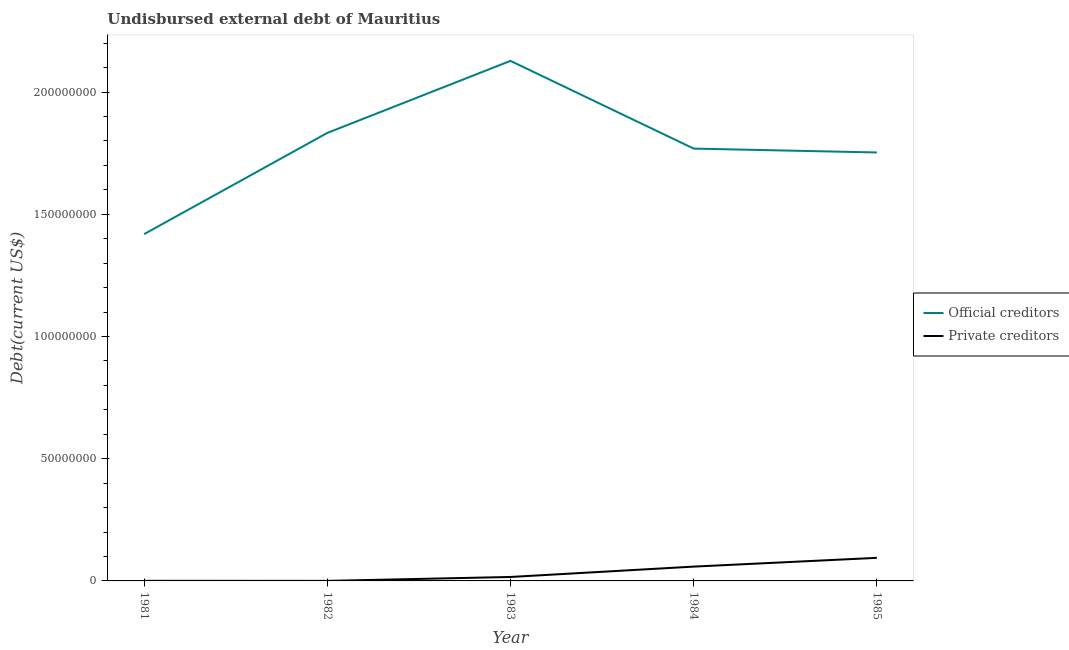How many different coloured lines are there?
Your answer should be very brief. 2. Is the number of lines equal to the number of legend labels?
Your response must be concise. Yes. What is the undisbursed external debt of private creditors in 1985?
Offer a terse response. 9.44e+06. Across all years, what is the maximum undisbursed external debt of official creditors?
Give a very brief answer. 2.13e+08. Across all years, what is the minimum undisbursed external debt of private creditors?
Give a very brief answer. 1.90e+04. In which year was the undisbursed external debt of official creditors maximum?
Your answer should be very brief. 1983. What is the total undisbursed external debt of private creditors in the graph?
Ensure brevity in your answer.  1.70e+07. What is the difference between the undisbursed external debt of private creditors in 1982 and that in 1984?
Ensure brevity in your answer.  -5.84e+06. What is the difference between the undisbursed external debt of private creditors in 1983 and the undisbursed external debt of official creditors in 1985?
Your response must be concise. -1.74e+08. What is the average undisbursed external debt of private creditors per year?
Your answer should be compact. 3.40e+06. In the year 1983, what is the difference between the undisbursed external debt of private creditors and undisbursed external debt of official creditors?
Offer a very short reply. -2.11e+08. In how many years, is the undisbursed external debt of official creditors greater than 210000000 US$?
Your response must be concise. 1. What is the ratio of the undisbursed external debt of private creditors in 1981 to that in 1984?
Your answer should be very brief. 0.01. Is the undisbursed external debt of private creditors in 1982 less than that in 1985?
Provide a succinct answer. Yes. Is the difference between the undisbursed external debt of official creditors in 1983 and 1984 greater than the difference between the undisbursed external debt of private creditors in 1983 and 1984?
Give a very brief answer. Yes. What is the difference between the highest and the second highest undisbursed external debt of private creditors?
Make the answer very short. 3.58e+06. What is the difference between the highest and the lowest undisbursed external debt of private creditors?
Offer a terse response. 9.42e+06. Is the sum of the undisbursed external debt of official creditors in 1981 and 1984 greater than the maximum undisbursed external debt of private creditors across all years?
Provide a short and direct response. Yes. Is the undisbursed external debt of private creditors strictly greater than the undisbursed external debt of official creditors over the years?
Offer a very short reply. No. How many years are there in the graph?
Give a very brief answer. 5. What is the difference between two consecutive major ticks on the Y-axis?
Your response must be concise. 5.00e+07. How many legend labels are there?
Your response must be concise. 2. What is the title of the graph?
Provide a succinct answer. Undisbursed external debt of Mauritius. What is the label or title of the Y-axis?
Provide a short and direct response. Debt(current US$). What is the Debt(current US$) in Official creditors in 1981?
Provide a short and direct response. 1.42e+08. What is the Debt(current US$) in Private creditors in 1981?
Provide a short and direct response. 4.60e+04. What is the Debt(current US$) in Official creditors in 1982?
Offer a terse response. 1.83e+08. What is the Debt(current US$) in Private creditors in 1982?
Provide a succinct answer. 1.90e+04. What is the Debt(current US$) in Official creditors in 1983?
Your answer should be very brief. 2.13e+08. What is the Debt(current US$) of Private creditors in 1983?
Provide a short and direct response. 1.62e+06. What is the Debt(current US$) of Official creditors in 1984?
Offer a terse response. 1.77e+08. What is the Debt(current US$) of Private creditors in 1984?
Offer a very short reply. 5.86e+06. What is the Debt(current US$) in Official creditors in 1985?
Your response must be concise. 1.75e+08. What is the Debt(current US$) of Private creditors in 1985?
Your response must be concise. 9.44e+06. Across all years, what is the maximum Debt(current US$) in Official creditors?
Provide a succinct answer. 2.13e+08. Across all years, what is the maximum Debt(current US$) of Private creditors?
Provide a short and direct response. 9.44e+06. Across all years, what is the minimum Debt(current US$) in Official creditors?
Keep it short and to the point. 1.42e+08. Across all years, what is the minimum Debt(current US$) of Private creditors?
Keep it short and to the point. 1.90e+04. What is the total Debt(current US$) of Official creditors in the graph?
Provide a succinct answer. 8.90e+08. What is the total Debt(current US$) in Private creditors in the graph?
Keep it short and to the point. 1.70e+07. What is the difference between the Debt(current US$) of Official creditors in 1981 and that in 1982?
Keep it short and to the point. -4.14e+07. What is the difference between the Debt(current US$) in Private creditors in 1981 and that in 1982?
Keep it short and to the point. 2.70e+04. What is the difference between the Debt(current US$) in Official creditors in 1981 and that in 1983?
Offer a very short reply. -7.09e+07. What is the difference between the Debt(current US$) in Private creditors in 1981 and that in 1983?
Provide a succinct answer. -1.57e+06. What is the difference between the Debt(current US$) of Official creditors in 1981 and that in 1984?
Make the answer very short. -3.50e+07. What is the difference between the Debt(current US$) in Private creditors in 1981 and that in 1984?
Provide a short and direct response. -5.81e+06. What is the difference between the Debt(current US$) in Official creditors in 1981 and that in 1985?
Keep it short and to the point. -3.34e+07. What is the difference between the Debt(current US$) in Private creditors in 1981 and that in 1985?
Your answer should be compact. -9.39e+06. What is the difference between the Debt(current US$) of Official creditors in 1982 and that in 1983?
Provide a short and direct response. -2.95e+07. What is the difference between the Debt(current US$) of Private creditors in 1982 and that in 1983?
Provide a succinct answer. -1.60e+06. What is the difference between the Debt(current US$) in Official creditors in 1982 and that in 1984?
Keep it short and to the point. 6.41e+06. What is the difference between the Debt(current US$) of Private creditors in 1982 and that in 1984?
Your answer should be very brief. -5.84e+06. What is the difference between the Debt(current US$) in Official creditors in 1982 and that in 1985?
Offer a terse response. 8.00e+06. What is the difference between the Debt(current US$) of Private creditors in 1982 and that in 1985?
Provide a succinct answer. -9.42e+06. What is the difference between the Debt(current US$) of Official creditors in 1983 and that in 1984?
Give a very brief answer. 3.59e+07. What is the difference between the Debt(current US$) of Private creditors in 1983 and that in 1984?
Offer a very short reply. -4.24e+06. What is the difference between the Debt(current US$) of Official creditors in 1983 and that in 1985?
Make the answer very short. 3.75e+07. What is the difference between the Debt(current US$) in Private creditors in 1983 and that in 1985?
Offer a terse response. -7.82e+06. What is the difference between the Debt(current US$) of Official creditors in 1984 and that in 1985?
Keep it short and to the point. 1.59e+06. What is the difference between the Debt(current US$) in Private creditors in 1984 and that in 1985?
Provide a short and direct response. -3.58e+06. What is the difference between the Debt(current US$) in Official creditors in 1981 and the Debt(current US$) in Private creditors in 1982?
Offer a terse response. 1.42e+08. What is the difference between the Debt(current US$) in Official creditors in 1981 and the Debt(current US$) in Private creditors in 1983?
Provide a short and direct response. 1.40e+08. What is the difference between the Debt(current US$) in Official creditors in 1981 and the Debt(current US$) in Private creditors in 1984?
Provide a succinct answer. 1.36e+08. What is the difference between the Debt(current US$) in Official creditors in 1981 and the Debt(current US$) in Private creditors in 1985?
Offer a terse response. 1.32e+08. What is the difference between the Debt(current US$) in Official creditors in 1982 and the Debt(current US$) in Private creditors in 1983?
Make the answer very short. 1.82e+08. What is the difference between the Debt(current US$) of Official creditors in 1982 and the Debt(current US$) of Private creditors in 1984?
Ensure brevity in your answer.  1.77e+08. What is the difference between the Debt(current US$) of Official creditors in 1982 and the Debt(current US$) of Private creditors in 1985?
Provide a succinct answer. 1.74e+08. What is the difference between the Debt(current US$) in Official creditors in 1983 and the Debt(current US$) in Private creditors in 1984?
Your answer should be compact. 2.07e+08. What is the difference between the Debt(current US$) in Official creditors in 1983 and the Debt(current US$) in Private creditors in 1985?
Keep it short and to the point. 2.03e+08. What is the difference between the Debt(current US$) of Official creditors in 1984 and the Debt(current US$) of Private creditors in 1985?
Provide a succinct answer. 1.67e+08. What is the average Debt(current US$) of Official creditors per year?
Ensure brevity in your answer.  1.78e+08. What is the average Debt(current US$) of Private creditors per year?
Offer a very short reply. 3.40e+06. In the year 1981, what is the difference between the Debt(current US$) of Official creditors and Debt(current US$) of Private creditors?
Make the answer very short. 1.42e+08. In the year 1982, what is the difference between the Debt(current US$) in Official creditors and Debt(current US$) in Private creditors?
Provide a short and direct response. 1.83e+08. In the year 1983, what is the difference between the Debt(current US$) in Official creditors and Debt(current US$) in Private creditors?
Provide a succinct answer. 2.11e+08. In the year 1984, what is the difference between the Debt(current US$) of Official creditors and Debt(current US$) of Private creditors?
Your answer should be very brief. 1.71e+08. In the year 1985, what is the difference between the Debt(current US$) of Official creditors and Debt(current US$) of Private creditors?
Ensure brevity in your answer.  1.66e+08. What is the ratio of the Debt(current US$) of Official creditors in 1981 to that in 1982?
Give a very brief answer. 0.77. What is the ratio of the Debt(current US$) of Private creditors in 1981 to that in 1982?
Provide a short and direct response. 2.42. What is the ratio of the Debt(current US$) in Official creditors in 1981 to that in 1983?
Provide a succinct answer. 0.67. What is the ratio of the Debt(current US$) in Private creditors in 1981 to that in 1983?
Keep it short and to the point. 0.03. What is the ratio of the Debt(current US$) in Official creditors in 1981 to that in 1984?
Offer a very short reply. 0.8. What is the ratio of the Debt(current US$) in Private creditors in 1981 to that in 1984?
Keep it short and to the point. 0.01. What is the ratio of the Debt(current US$) of Official creditors in 1981 to that in 1985?
Keep it short and to the point. 0.81. What is the ratio of the Debt(current US$) of Private creditors in 1981 to that in 1985?
Provide a succinct answer. 0. What is the ratio of the Debt(current US$) of Official creditors in 1982 to that in 1983?
Ensure brevity in your answer.  0.86. What is the ratio of the Debt(current US$) in Private creditors in 1982 to that in 1983?
Your answer should be very brief. 0.01. What is the ratio of the Debt(current US$) of Official creditors in 1982 to that in 1984?
Provide a succinct answer. 1.04. What is the ratio of the Debt(current US$) in Private creditors in 1982 to that in 1984?
Your answer should be very brief. 0. What is the ratio of the Debt(current US$) in Official creditors in 1982 to that in 1985?
Offer a very short reply. 1.05. What is the ratio of the Debt(current US$) in Private creditors in 1982 to that in 1985?
Your answer should be compact. 0. What is the ratio of the Debt(current US$) in Official creditors in 1983 to that in 1984?
Your answer should be very brief. 1.2. What is the ratio of the Debt(current US$) in Private creditors in 1983 to that in 1984?
Give a very brief answer. 0.28. What is the ratio of the Debt(current US$) of Official creditors in 1983 to that in 1985?
Ensure brevity in your answer.  1.21. What is the ratio of the Debt(current US$) in Private creditors in 1983 to that in 1985?
Your answer should be compact. 0.17. What is the ratio of the Debt(current US$) of Official creditors in 1984 to that in 1985?
Provide a succinct answer. 1.01. What is the ratio of the Debt(current US$) of Private creditors in 1984 to that in 1985?
Provide a short and direct response. 0.62. What is the difference between the highest and the second highest Debt(current US$) of Official creditors?
Provide a short and direct response. 2.95e+07. What is the difference between the highest and the second highest Debt(current US$) in Private creditors?
Provide a short and direct response. 3.58e+06. What is the difference between the highest and the lowest Debt(current US$) of Official creditors?
Give a very brief answer. 7.09e+07. What is the difference between the highest and the lowest Debt(current US$) of Private creditors?
Your response must be concise. 9.42e+06. 